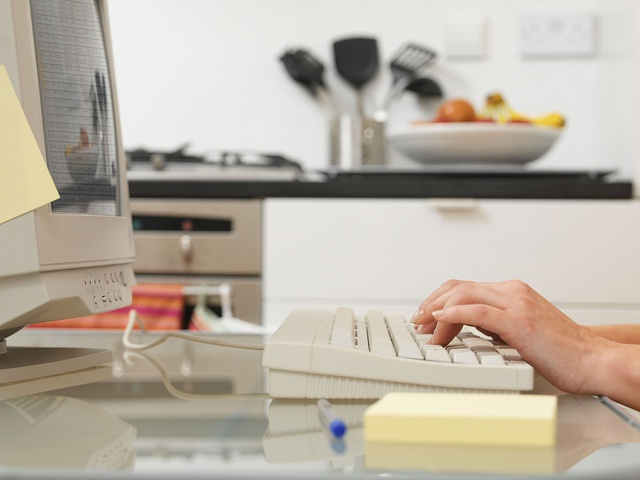Describe the objects in this image and their specific colors. I can see tv in darkgray, gray, and khaki tones, oven in darkgray, gray, and black tones, keyboard in darkgray, lightgray, and tan tones, people in darkgray, tan, brown, and salmon tones, and bowl in darkgray, gray, lightgray, and tan tones in this image. 